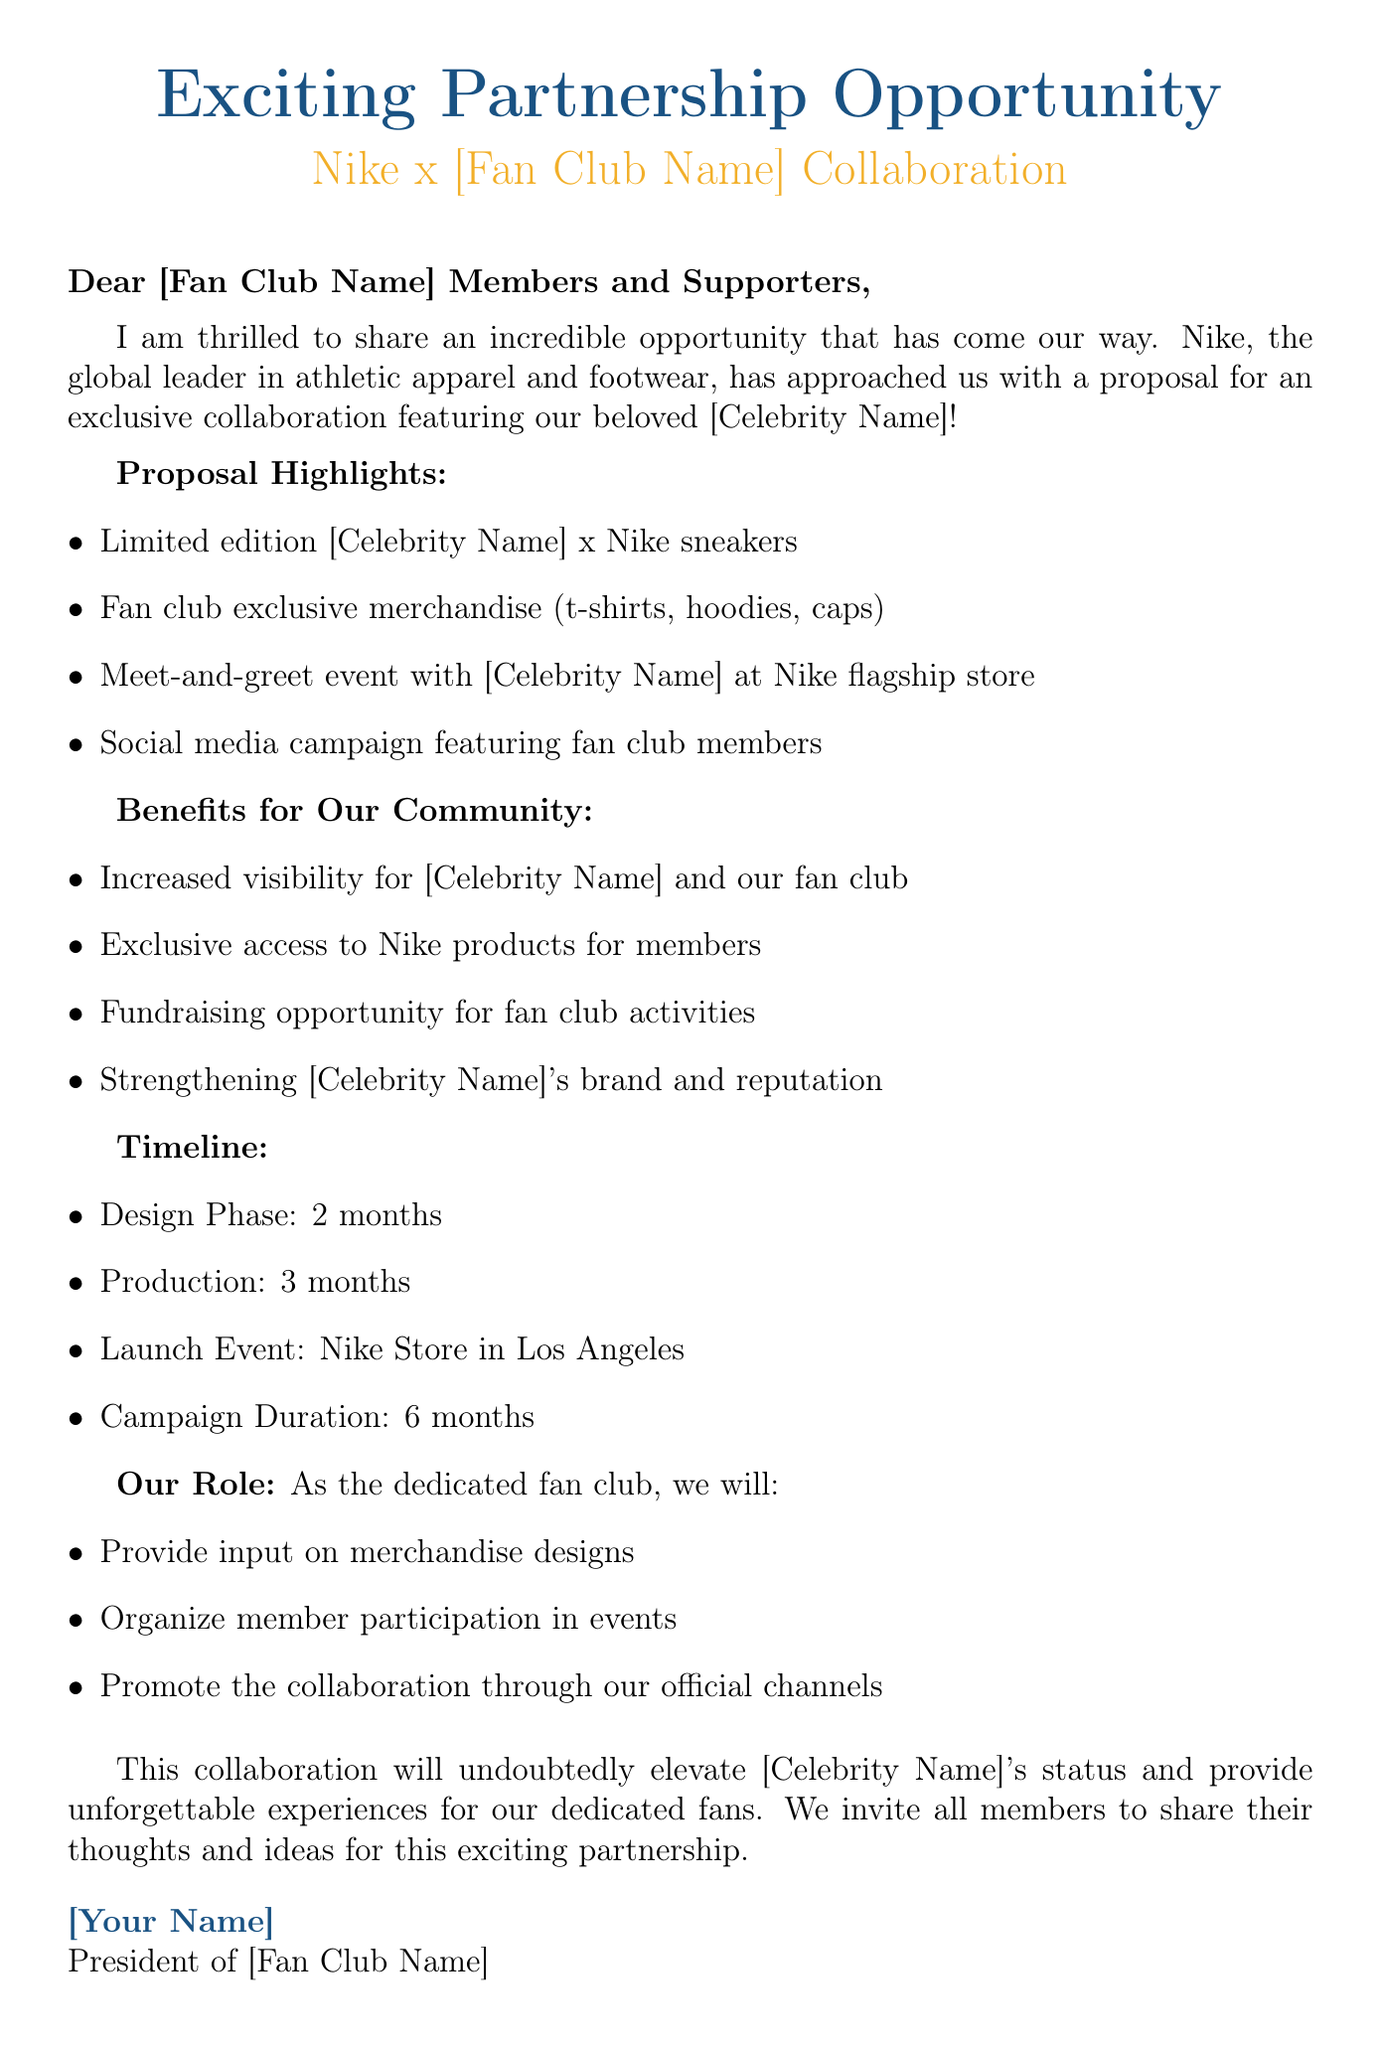What is the name of the brand collaborating with the fan club? The brand initiating the collaboration in the document is Nike.
Answer: Nike Who is the celebrity featured in the collaboration? The document indicates that the collaboration features a celebrity, but the specific name is represented as [Celebrity Name].
Answer: [Celebrity Name] How long is the design phase for the merchandise? According to the timeline in the proposal, the design phase is specified to last for 2 months.
Answer: 2 months What type of exclusive merchandise will fans receive? The proposal highlights fan club exclusive merchandise which includes t-shirts, hoodies, and caps.
Answer: t-shirts, hoodies, caps What is one key benefit for the fan club mentioned in the document? One of the benefits mentioned in the document is exclusive access to Nike products for members.
Answer: Exclusive access to Nike products What is the location for the launch event? The document states that the launch event will take place at the Nike Store in Los Angeles.
Answer: Nike Store in Los Angeles What are fan club members invited to share? The closing section invites members to share their thoughts and ideas regarding the partnership.
Answer: Their thoughts and ideas How long will the campaign duration last? The document outlines that the campaign duration is set for 6 months.
Answer: 6 months What are fan club members asked to organize? The document specifies that fan club members are responsible for organizing member participation in events.
Answer: Member participation in events 